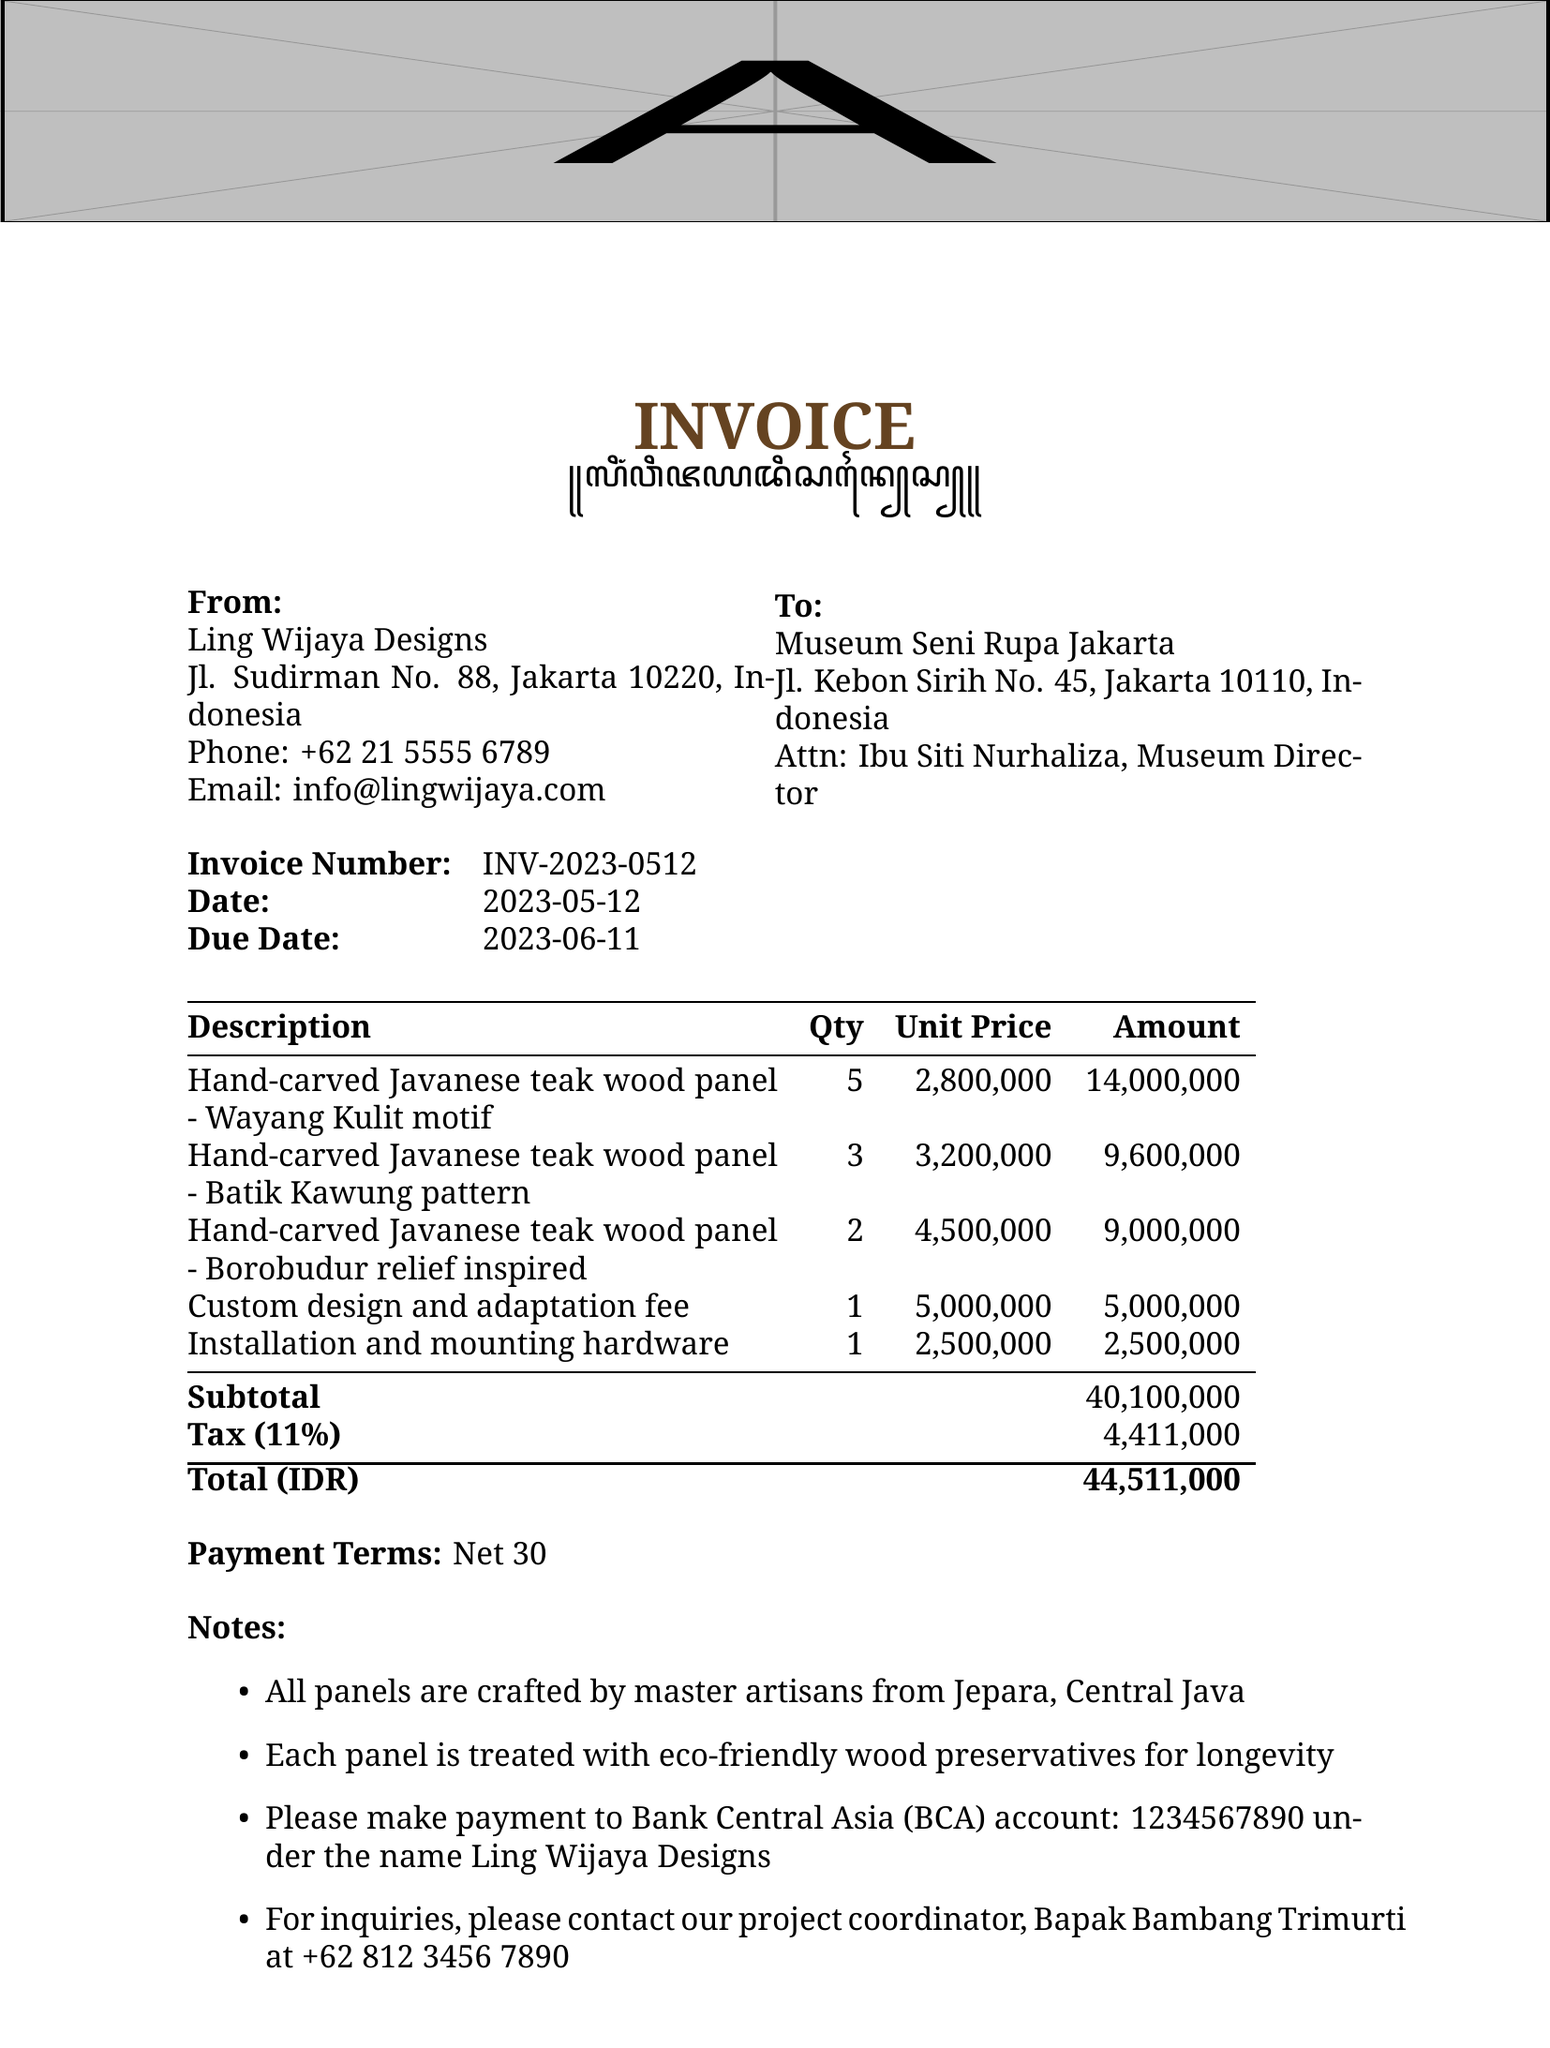what is the invoice number? The invoice number is mentioned at the top of the invoice, which serves as a reference for the transaction.
Answer: INV-2023-0512 what is the due date of the invoice? The due date is specified in the document to indicate when payment is expected to be made.
Answer: 2023-06-11 who is the architect for the project? The architect's name is provided in the additional information section related to the project.
Answer: Ling Wijaya how many panels are there with the Batik Kawung pattern? The quantity of panels refers to how many of that specific design are included in the invoice.
Answer: 3 what is the subtotal amount before tax? The subtotal represents the total of all items listed before taxes are added.
Answer: 40,100,000 what is the total amount due? The total due is the final amount after including tax, which is indicated at the bottom of the document.
Answer: 44,511,000 what is the tax rate applied to the invoice? The tax rate is mentioned in the invoice details section and is essential for calculating the total amount due.
Answer: 11% who should the payment be made to? This information indicates the name under which the bank account is registered for payment purposes.
Answer: Ling Wijaya Designs what is the warranty period for the craftsmanship? The warranty period is provided in the additional information section, reflecting the guarantee for quality.
Answer: 5 years limited warranty 